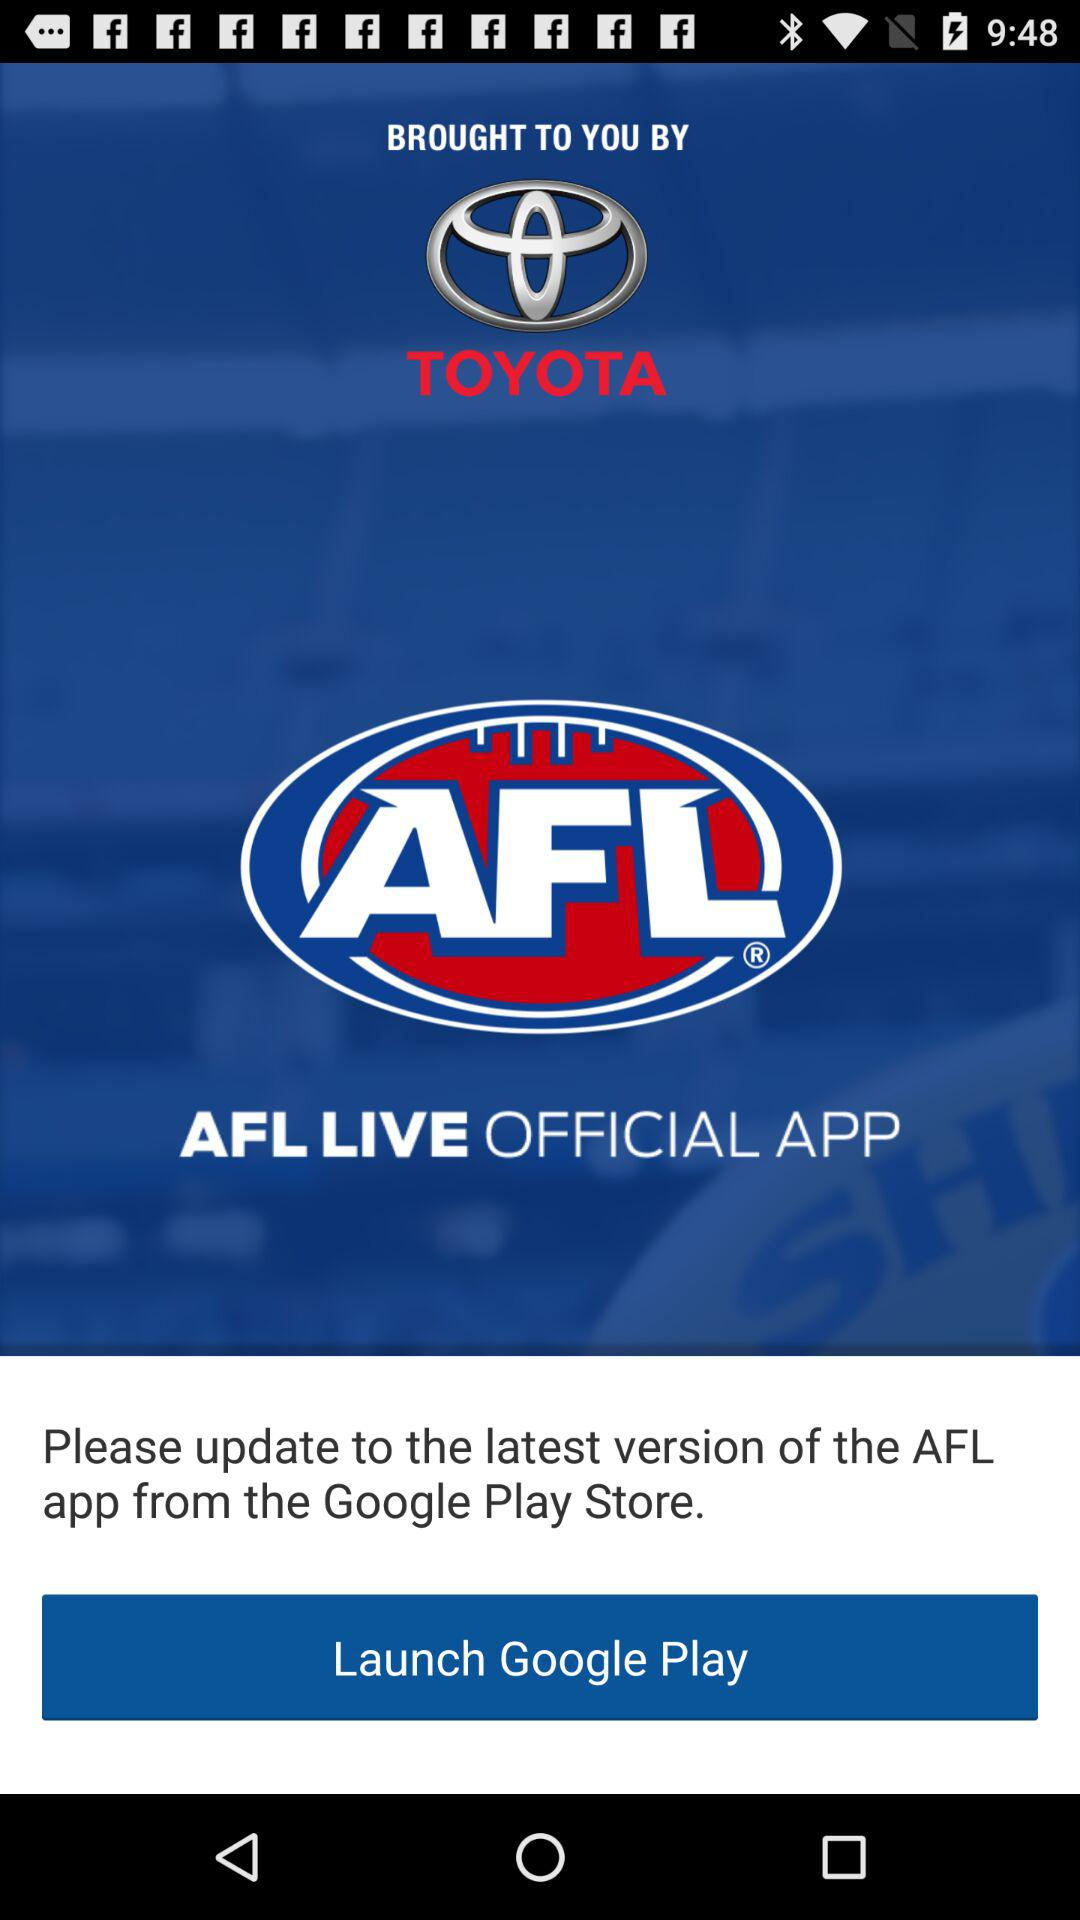What is the name of the application? The name of the application is "AFL LIVE OFFICIAL". 